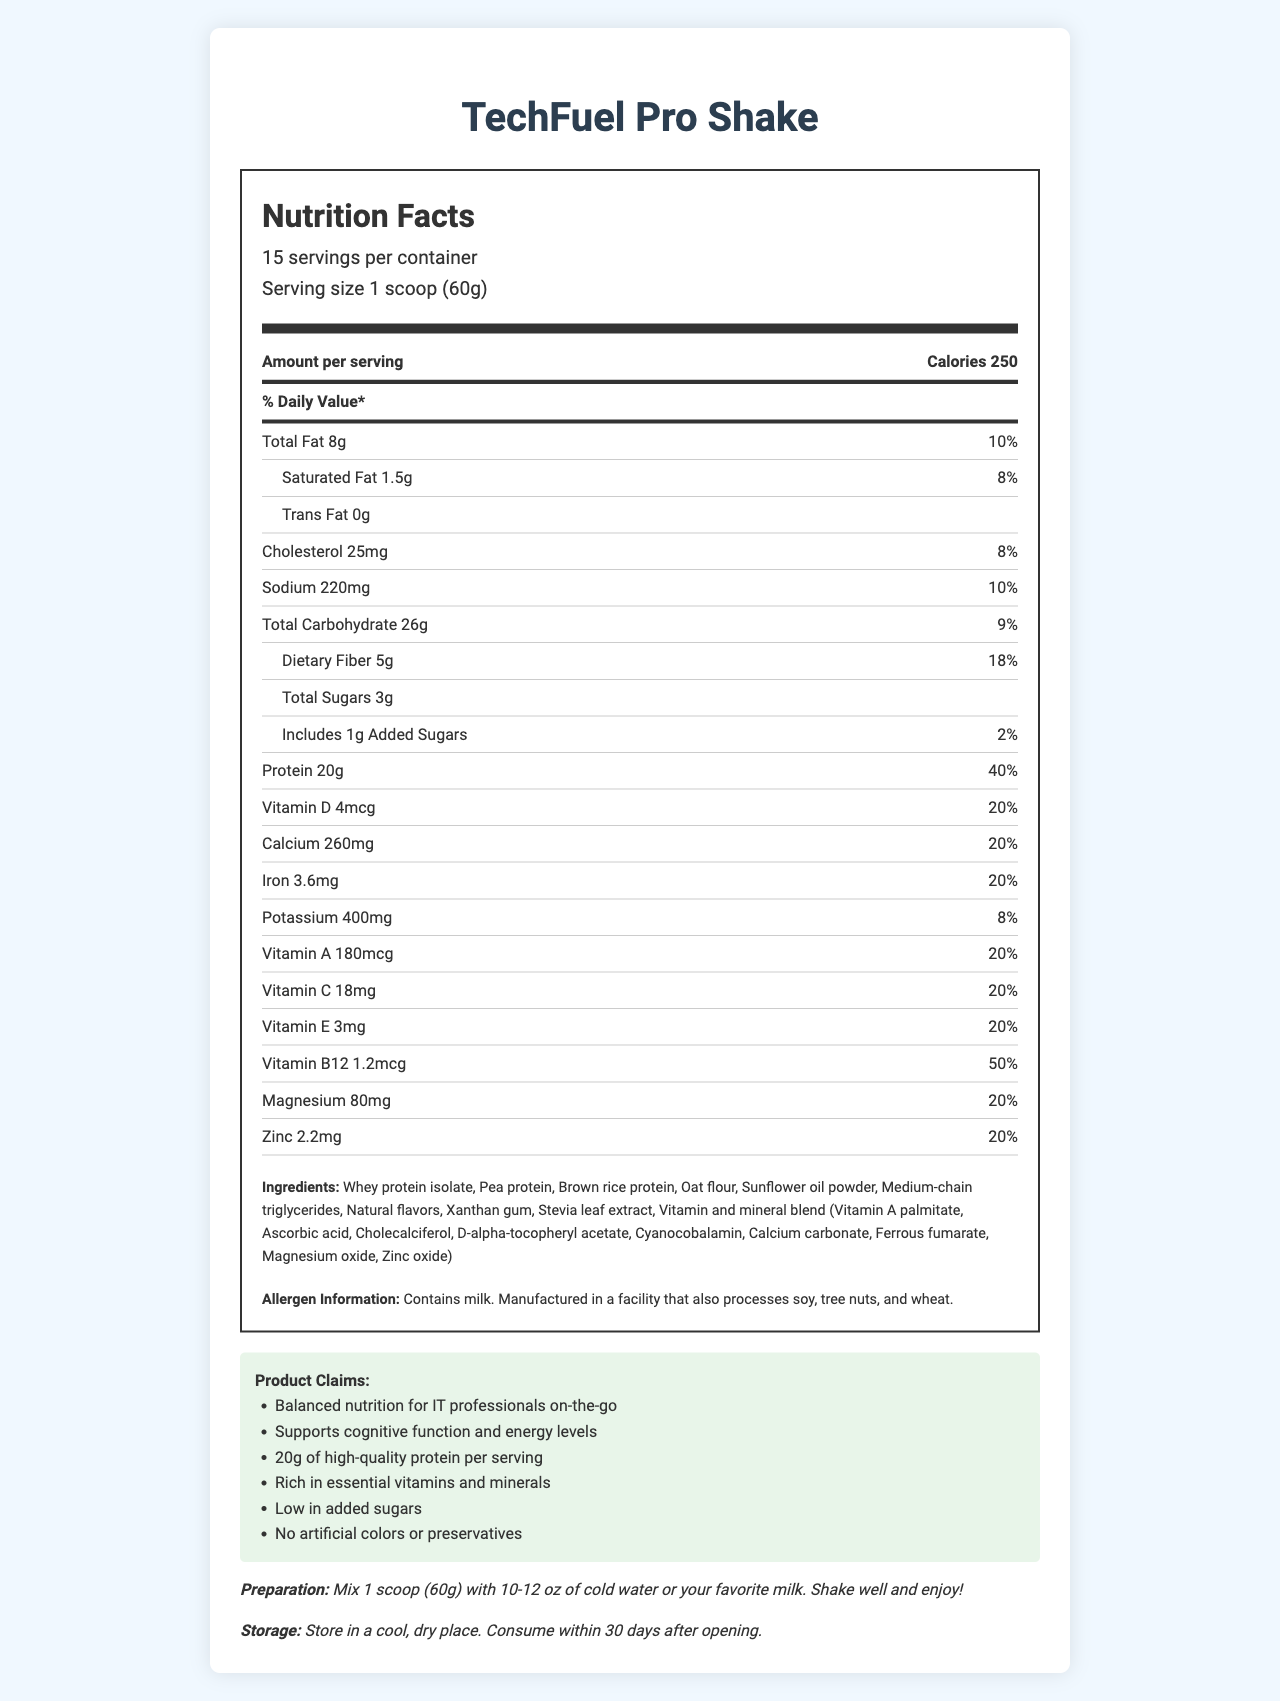what is the serving size? The document lists the serving size as "1 scoop (60g)" under the serving information header.
Answer: 1 scoop (60g) how many calories are there per serving? The calories per serving are listed directly as "Calories 250" in the document.
Answer: 250 what are the total fats in one serving? The total fats are listed as "Total Fat 8g" in the nutrient information section.
Answer: 8g how much dietary fiber does TechFuel Pro Shake contain per serving? The dietary fiber is mentioned as "Dietary Fiber 5g" in the sub-nutrient section of the carbohydrate row.
Answer: 5g how many grams of protein are in one serving? The protein content per serving is specified as "Protein 20g" in the nutrient information section.
Answer: 20g what is the percentage daily value of Vitamin D in TechFuel Pro Shake? The document states Vitamin D as "Vitamin D 4mcg, 20%" in the nutrient information section.
Answer: 20% which ingredient can be found in TechFuel Pro Shake? A. Wheat protein B. Whey protein isolate C. Soy protein The ingredients list includes "Whey protein isolate" but neither wheat protein nor soy protein.
Answer: B how much added sugars are in one serving? A. 0g B. 1g C. 3g D. 5g The document lists the added sugars as "Includes 1g Added Sugars" in the sub-nutrient section.
Answer: B does the product contain any trans fats? The document specifies "Trans Fat 0g" in the sub-nutrient section.
Answer: No does TechFuel Pro Shake include vitamin B12? The nutrient information section lists "Vitamin B12 1.2mcg" with a daily value of 50%.
Answer: Yes summarize the nutrition and features of TechFuel Pro Shake. The explanation includes a comprehensive description of the document, summarizing the nutritional content, ingredient list, and product claims.
Answer: TechFuel Pro Shake is a nutrient-dense meal replacement shake tailored for busy IT professionals. Each 60g serving offers 250 calories, 8g of total fat, 20g of protein, and 26g of carbohydrates including 5g dietary fiber and 3g sugars (1g added). It is rich in essential vitamins and minerals including a 20% daily value of Vitamin D, A, C, E, calcium, iron, magnesium, and more. It contains natural ingredients like whey protein isolate, pea protein, and sunflower oil powder and claims to support cognitive function and energy levels. is the preparation method of this shake mixing with hot water? The preparation section clearly states to "Mix 1 scoop (60g) with 10-12 oz of cold water or your favorite milk."
Answer: No is the product suitable for someone with a nut allergy? While the allergen information mentions milk and processing in a facility that handles soy, tree nuts, and wheat, it does not explicitly state whether the product is suitable for those with nut allergies.
Answer: Cannot be determined what are the four main claims of TechFuel Pro Shake? A. Balanced nutrition, B. Low-calorie count, C. Supports cognitive function, D. High protein, E. Gluten-free, F. No artificial colors The product claims include "Balanced nutrition for IT professionals on-the-go," "Supports cognitive function and energy levels," "20g of high-quality protein per serving," and "No artificial colors or preservatives."
Answer: A, C, D, F 